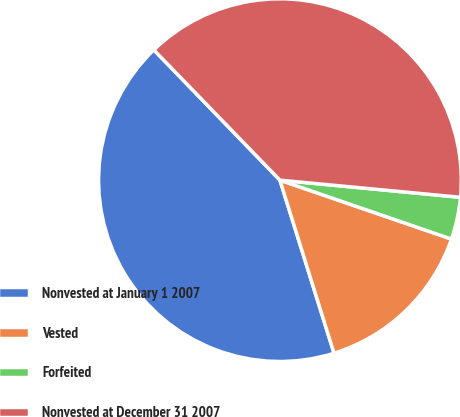<chart> <loc_0><loc_0><loc_500><loc_500><pie_chart><fcel>Nonvested at January 1 2007<fcel>Vested<fcel>Forfeited<fcel>Nonvested at December 31 2007<nl><fcel>42.58%<fcel>14.91%<fcel>3.76%<fcel>38.75%<nl></chart> 